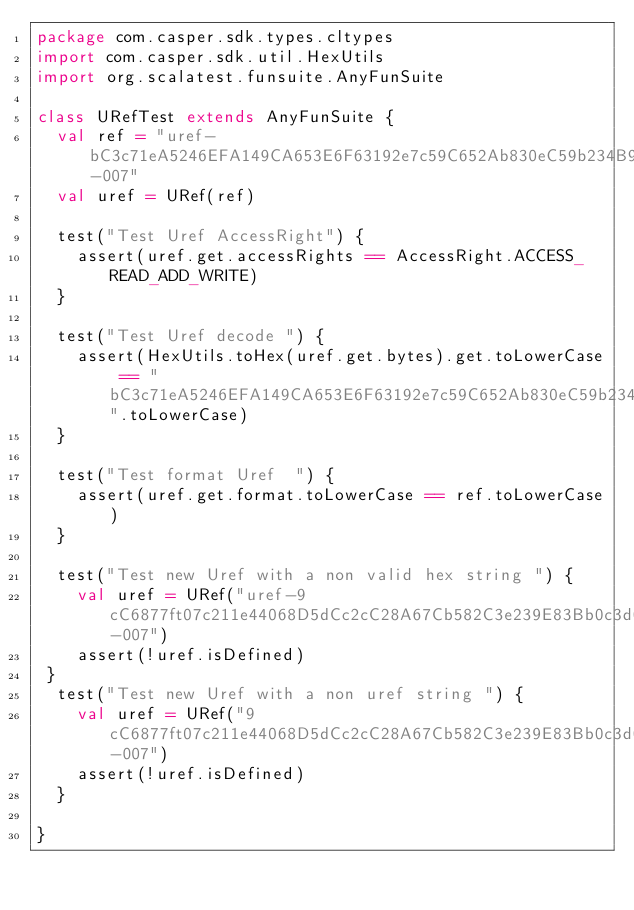Convert code to text. <code><loc_0><loc_0><loc_500><loc_500><_Scala_>package com.casper.sdk.types.cltypes
import com.casper.sdk.util.HexUtils
import org.scalatest.funsuite.AnyFunSuite

class URefTest extends AnyFunSuite {
  val ref = "uref-bC3c71eA5246EFA149CA653E6F63192e7c59C652Ab830eC59b234B99bfA0B109-007"
  val uref = URef(ref)

  test("Test Uref AccessRight") {
    assert(uref.get.accessRights == AccessRight.ACCESS_READ_ADD_WRITE)
  }

  test("Test Uref decode ") {
    assert(HexUtils.toHex(uref.get.bytes).get.toLowerCase == "bC3c71eA5246EFA149CA653E6F63192e7c59C652Ab830eC59b234B99bfA0B109".toLowerCase)
  }

  test("Test format Uref  ") {
    assert(uref.get.format.toLowerCase == ref.toLowerCase)
  }

  test("Test new Uref with a non valid hex string ") {
    val uref = URef("uref-9cC6877ft07c211e44068D5dCc2cC28A67Cb582C3e239E83Bb0c3d067C4D0363-007")
    assert(!uref.isDefined)
 }
  test("Test new Uref with a non uref string ") {
    val uref = URef("9cC6877ft07c211e44068D5dCc2cC28A67Cb582C3e239E83Bb0c3d067C4D0363-007")
    assert(!uref.isDefined)
  }

}
</code> 